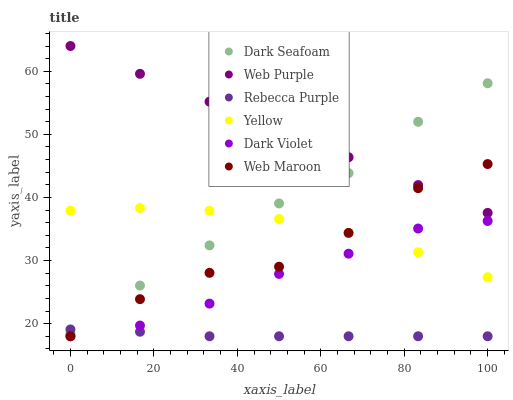Does Rebecca Purple have the minimum area under the curve?
Answer yes or no. Yes. Does Web Purple have the maximum area under the curve?
Answer yes or no. Yes. Does Dark Violet have the minimum area under the curve?
Answer yes or no. No. Does Dark Violet have the maximum area under the curve?
Answer yes or no. No. Is Web Purple the smoothest?
Answer yes or no. Yes. Is Web Maroon the roughest?
Answer yes or no. Yes. Is Dark Violet the smoothest?
Answer yes or no. No. Is Dark Violet the roughest?
Answer yes or no. No. Does Web Maroon have the lowest value?
Answer yes or no. Yes. Does Web Purple have the lowest value?
Answer yes or no. No. Does Web Purple have the highest value?
Answer yes or no. Yes. Does Dark Violet have the highest value?
Answer yes or no. No. Is Dark Violet less than Dark Seafoam?
Answer yes or no. Yes. Is Web Purple greater than Rebecca Purple?
Answer yes or no. Yes. Does Yellow intersect Dark Seafoam?
Answer yes or no. Yes. Is Yellow less than Dark Seafoam?
Answer yes or no. No. Is Yellow greater than Dark Seafoam?
Answer yes or no. No. Does Dark Violet intersect Dark Seafoam?
Answer yes or no. No. 